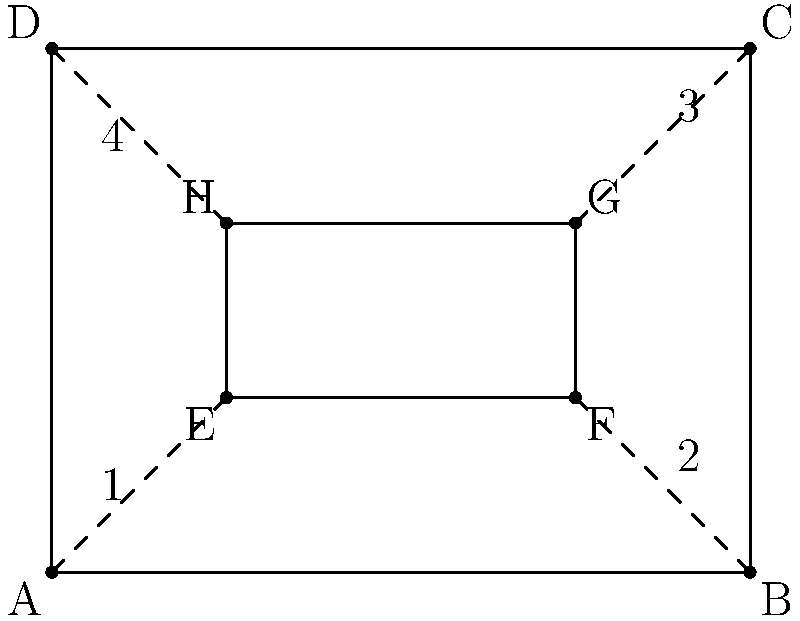In this child safety gate installation diagram for a doorway, which pair of angles are congruent and crucial for ensuring the gate is properly aligned and secure? To determine which pair of angles are congruent and crucial for the child safety gate installation, let's follow these steps:

1. Observe that the diagram shows a rectangular doorway (ABCD) with a rectangular safety gate (EFGH) inside it.

2. The dashed lines represent the connection points between the doorway and the safety gate.

3. In a rectangle, opposite angles are always congruent. However, we need to focus on the angles that are crucial for proper alignment and security.

4. The most important angles for installation are those formed where the gate meets the doorway frame. These are labeled 1, 2, 3, and 4 in the diagram.

5. For proper alignment and security, the gate should be parallel to the doorway sides. This means that angle 1 should be congruent to angle 3, and angle 2 should be congruent to angle 4.

6. The most critical pair for installation stability would be either the top or bottom pair. Let's focus on the bottom pair: angles 1 and 2.

7. If angles 1 and 2 are congruent, it ensures that the bottom of the gate is perfectly level, which is crucial for stability and preventing the gate from being easily pushed over by a child.

Therefore, the pair of angles that are congruent and crucial for ensuring the gate is properly aligned and secure are angles 1 and 2.
Answer: Angles 1 and 2 